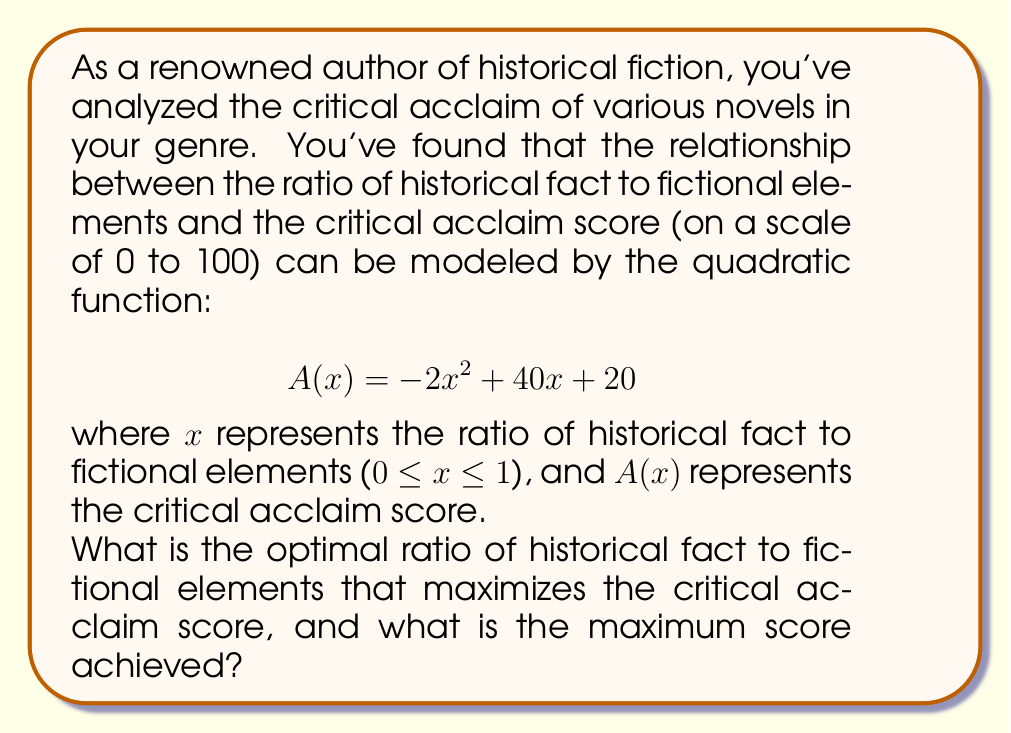Show me your answer to this math problem. To solve this optimization problem, we need to follow these steps:

1) The function $A(x) = -2x^2 + 40x + 20$ is a quadratic function, and its graph is a parabola that opens downward (because the coefficient of $x^2$ is negative).

2) The maximum point of a parabola occurs at the vertex. For a quadratic function in the form $f(x) = ax^2 + bx + c$, the x-coordinate of the vertex is given by $x = -\frac{b}{2a}$.

3) In our case, $a = -2$, $b = 40$, and $c = 20$. Let's calculate the x-coordinate of the vertex:

   $$x = -\frac{40}{2(-2)} = -\frac{40}{-4} = 10$$

4) This x-value represents the ratio that maximizes the critical acclaim score. However, we need to ensure it's within our domain of 0 ≤ x ≤ 1.

5) Since 10 is outside our domain, the maximum must occur at one of the endpoints of our interval. Let's evaluate $A(x)$ at $x = 0$ and $x = 1$:

   $A(0) = -2(0)^2 + 40(0) + 20 = 20$
   $A(1) = -2(1)^2 + 40(1) + 20 = 58$

6) The maximum occurs at $x = 1$, which corresponds to a ratio of 1:1 (equal parts historical fact and fictional elements).

7) The maximum critical acclaim score is 58.
Answer: The optimal ratio of historical fact to fictional elements is 1:1 (or 0.5:0.5), and the maximum critical acclaim score achieved is 58. 